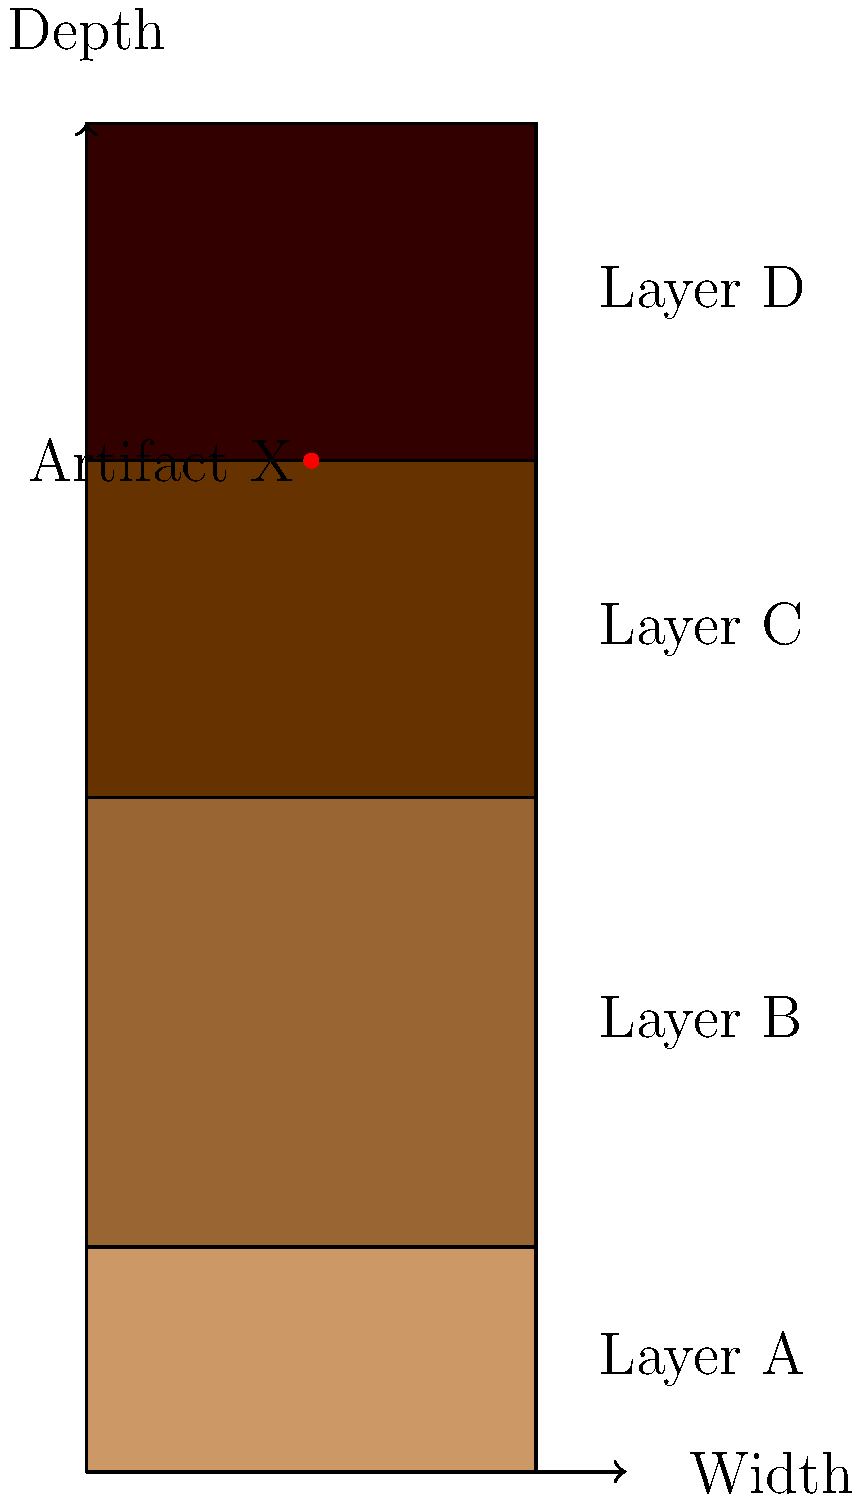In the stratigraphic diagram of an excavation site, an important artifact (Artifact X) has been discovered. Based on the principle of superposition and the location of Artifact X, which layer is likely to be the oldest, and what can we infer about the relative age of Artifact X? To answer this question, we need to follow these steps:

1. Understand the principle of superposition:
   - In undisturbed sedimentary layers, the oldest layers are at the bottom, and the youngest are at the top.

2. Analyze the stratigraphic diagram:
   - The diagram shows four distinct layers: A, B, C, and D (from top to bottom).
   - Layer D is at the bottom, suggesting it's the oldest layer.

3. Locate Artifact X:
   - Artifact X is found in Layer B, the second layer from the top.

4. Apply the principle of superposition:
   - Since Layer D is at the bottom, it is the oldest layer.
   - Layers C, B, and A were deposited sequentially on top of Layer D.

5. Determine the relative age of Artifact X:
   - Artifact X is in Layer B, which is older than Layer A but younger than Layers C and D.
   - This means Artifact X is relatively young compared to the entire stratigraphic sequence but not the youngest possible find.

6. Conclusion:
   - Layer D is the oldest layer.
   - Artifact X is younger than materials in Layers C and D but older than those in Layer A.
Answer: Layer D; Artifact X is relatively young but predates Layer A. 